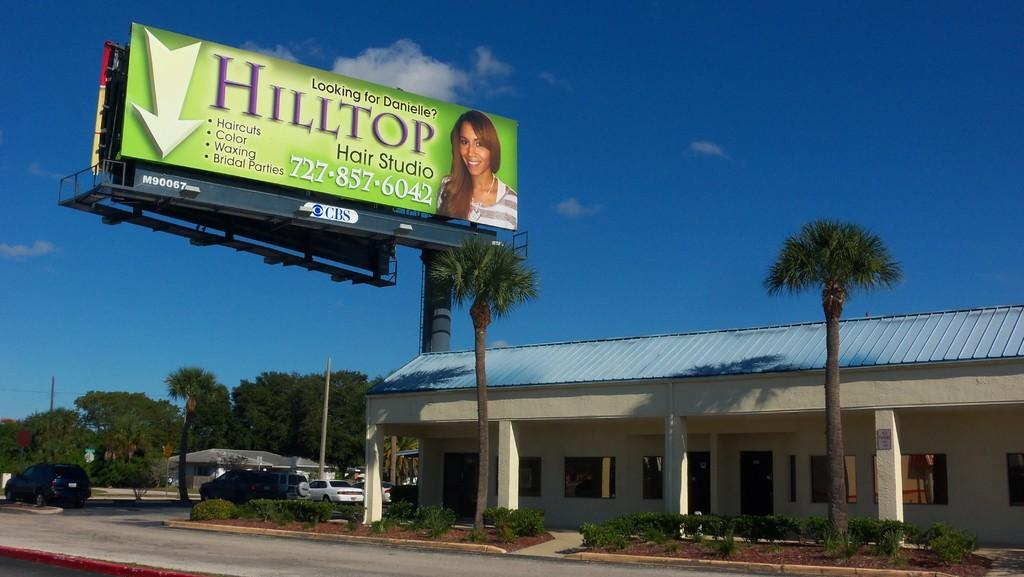<image>
Render a clear and concise summary of the photo. A billboard for Hilltop Hair Studio, which offers haircuts, color, waxing and bridal parties, with an arrow pointing straight down. 